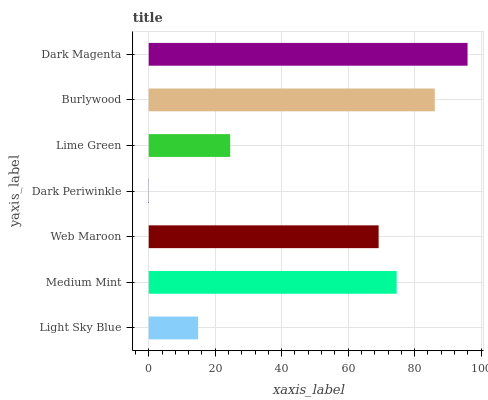Is Dark Periwinkle the minimum?
Answer yes or no. Yes. Is Dark Magenta the maximum?
Answer yes or no. Yes. Is Medium Mint the minimum?
Answer yes or no. No. Is Medium Mint the maximum?
Answer yes or no. No. Is Medium Mint greater than Light Sky Blue?
Answer yes or no. Yes. Is Light Sky Blue less than Medium Mint?
Answer yes or no. Yes. Is Light Sky Blue greater than Medium Mint?
Answer yes or no. No. Is Medium Mint less than Light Sky Blue?
Answer yes or no. No. Is Web Maroon the high median?
Answer yes or no. Yes. Is Web Maroon the low median?
Answer yes or no. Yes. Is Dark Periwinkle the high median?
Answer yes or no. No. Is Dark Periwinkle the low median?
Answer yes or no. No. 